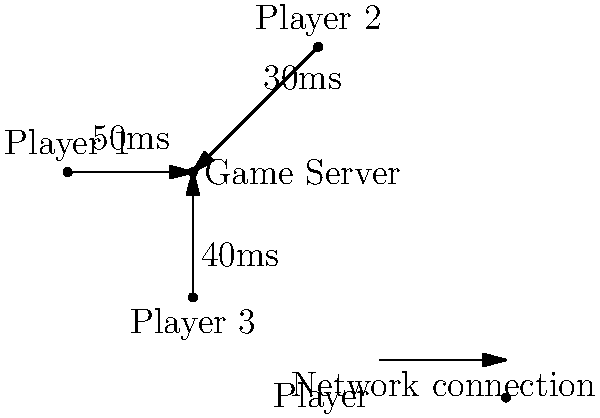In a multiplayer Marvel game, three players are connected to a central game server with different network latencies. Player 1 has a 50ms latency, Player 2 has a 30ms latency, and Player 3 has a 40ms latency. What is the maximum time difference between when Player 1 and Player 2 receive an update from the server, assuming the server sends the update simultaneously to all players? To solve this problem, we need to follow these steps:

1. Identify the latencies for each player:
   - Player 1: 50ms
   - Player 2: 30ms
   - Player 3: 40ms

2. Understand that latency is the time it takes for data to travel from the server to the player (or vice versa).

3. Realize that the maximum time difference will occur between the players with the highest and lowest latencies.

4. Identify the players with the highest and lowest latencies:
   - Highest latency: Player 1 (50ms)
   - Lowest latency: Player 2 (30ms)

5. Calculate the time difference:
   $Time_{difference} = Latency_{highest} - Latency_{lowest}$
   $Time_{difference} = 50ms - 30ms = 20ms$

Therefore, the maximum time difference between when Player 1 and Player 2 receive an update from the server is 20ms.
Answer: 20ms 